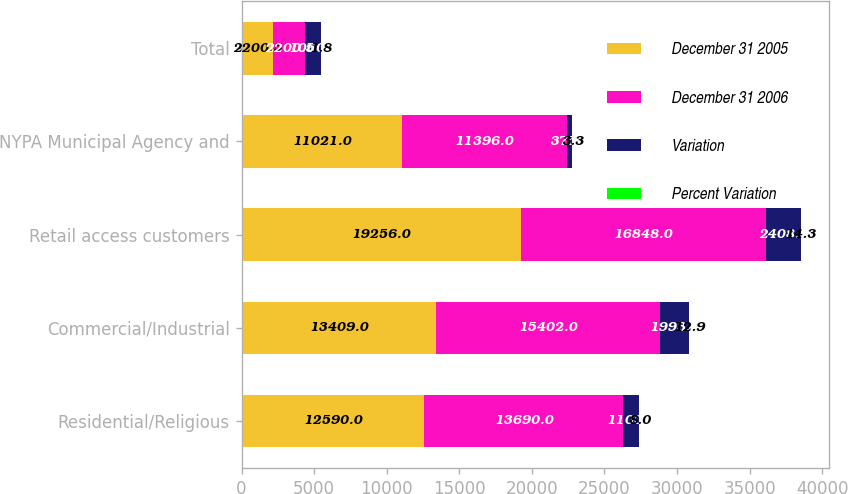Convert chart. <chart><loc_0><loc_0><loc_500><loc_500><stacked_bar_chart><ecel><fcel>Residential/Religious<fcel>Commercial/Industrial<fcel>Retail access customers<fcel>NYPA Municipal Agency and<fcel>Total<nl><fcel>December 31 2005<fcel>12590<fcel>13409<fcel>19256<fcel>11021<fcel>2200.5<nl><fcel>December 31 2006<fcel>13690<fcel>15402<fcel>16848<fcel>11396<fcel>2200.5<nl><fcel>Variation<fcel>1100<fcel>1993<fcel>2408<fcel>375<fcel>1060<nl><fcel>Percent Variation<fcel>8<fcel>12.9<fcel>14.3<fcel>3.3<fcel>1.8<nl></chart> 